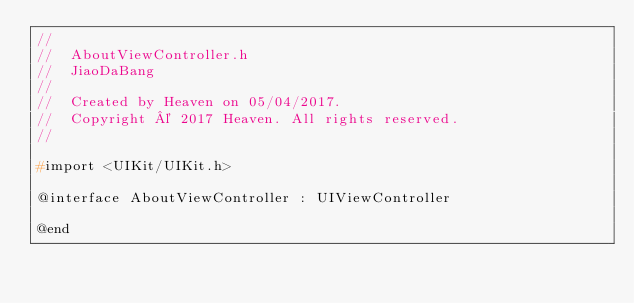Convert code to text. <code><loc_0><loc_0><loc_500><loc_500><_C_>//
//  AboutViewController.h
//  JiaoDaBang
//
//  Created by Heaven on 05/04/2017.
//  Copyright © 2017 Heaven. All rights reserved.
//

#import <UIKit/UIKit.h>

@interface AboutViewController : UIViewController

@end
</code> 